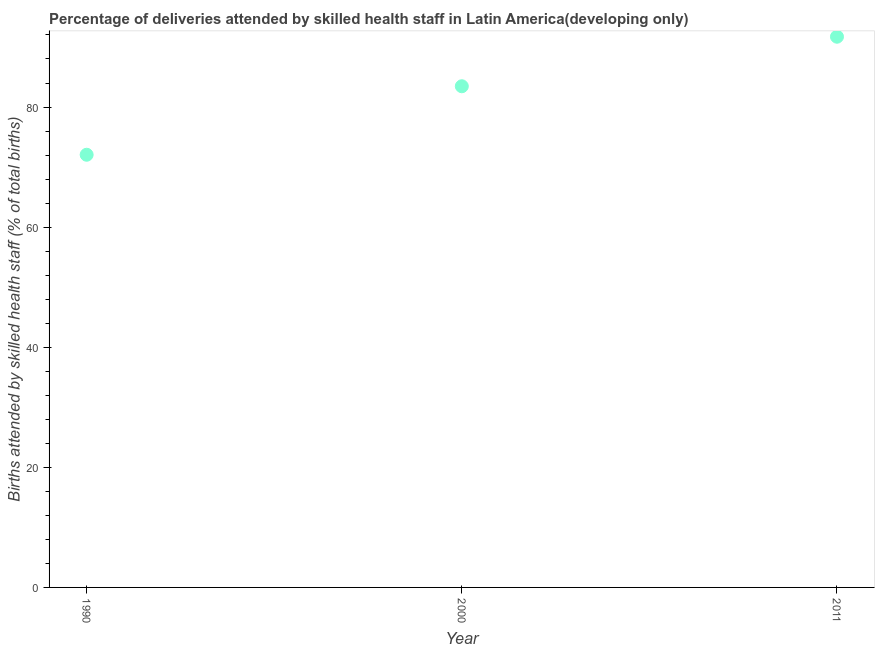What is the number of births attended by skilled health staff in 1990?
Offer a terse response. 72.05. Across all years, what is the maximum number of births attended by skilled health staff?
Give a very brief answer. 91.71. Across all years, what is the minimum number of births attended by skilled health staff?
Ensure brevity in your answer.  72.05. In which year was the number of births attended by skilled health staff maximum?
Provide a succinct answer. 2011. What is the sum of the number of births attended by skilled health staff?
Your response must be concise. 247.22. What is the difference between the number of births attended by skilled health staff in 1990 and 2011?
Provide a short and direct response. -19.65. What is the average number of births attended by skilled health staff per year?
Make the answer very short. 82.41. What is the median number of births attended by skilled health staff?
Ensure brevity in your answer.  83.46. In how many years, is the number of births attended by skilled health staff greater than 80 %?
Your answer should be compact. 2. What is the ratio of the number of births attended by skilled health staff in 1990 to that in 2011?
Keep it short and to the point. 0.79. Is the number of births attended by skilled health staff in 2000 less than that in 2011?
Make the answer very short. Yes. Is the difference between the number of births attended by skilled health staff in 1990 and 2000 greater than the difference between any two years?
Your answer should be very brief. No. What is the difference between the highest and the second highest number of births attended by skilled health staff?
Provide a succinct answer. 8.25. Is the sum of the number of births attended by skilled health staff in 1990 and 2011 greater than the maximum number of births attended by skilled health staff across all years?
Keep it short and to the point. Yes. What is the difference between the highest and the lowest number of births attended by skilled health staff?
Offer a terse response. 19.65. Does the number of births attended by skilled health staff monotonically increase over the years?
Make the answer very short. Yes. How many dotlines are there?
Keep it short and to the point. 1. How many years are there in the graph?
Your answer should be very brief. 3. What is the difference between two consecutive major ticks on the Y-axis?
Give a very brief answer. 20. Are the values on the major ticks of Y-axis written in scientific E-notation?
Your response must be concise. No. Does the graph contain any zero values?
Your answer should be compact. No. What is the title of the graph?
Provide a succinct answer. Percentage of deliveries attended by skilled health staff in Latin America(developing only). What is the label or title of the Y-axis?
Provide a succinct answer. Births attended by skilled health staff (% of total births). What is the Births attended by skilled health staff (% of total births) in 1990?
Your answer should be very brief. 72.05. What is the Births attended by skilled health staff (% of total births) in 2000?
Offer a terse response. 83.46. What is the Births attended by skilled health staff (% of total births) in 2011?
Ensure brevity in your answer.  91.71. What is the difference between the Births attended by skilled health staff (% of total births) in 1990 and 2000?
Your answer should be very brief. -11.41. What is the difference between the Births attended by skilled health staff (% of total births) in 1990 and 2011?
Your answer should be compact. -19.65. What is the difference between the Births attended by skilled health staff (% of total births) in 2000 and 2011?
Ensure brevity in your answer.  -8.25. What is the ratio of the Births attended by skilled health staff (% of total births) in 1990 to that in 2000?
Offer a terse response. 0.86. What is the ratio of the Births attended by skilled health staff (% of total births) in 1990 to that in 2011?
Ensure brevity in your answer.  0.79. What is the ratio of the Births attended by skilled health staff (% of total births) in 2000 to that in 2011?
Provide a short and direct response. 0.91. 